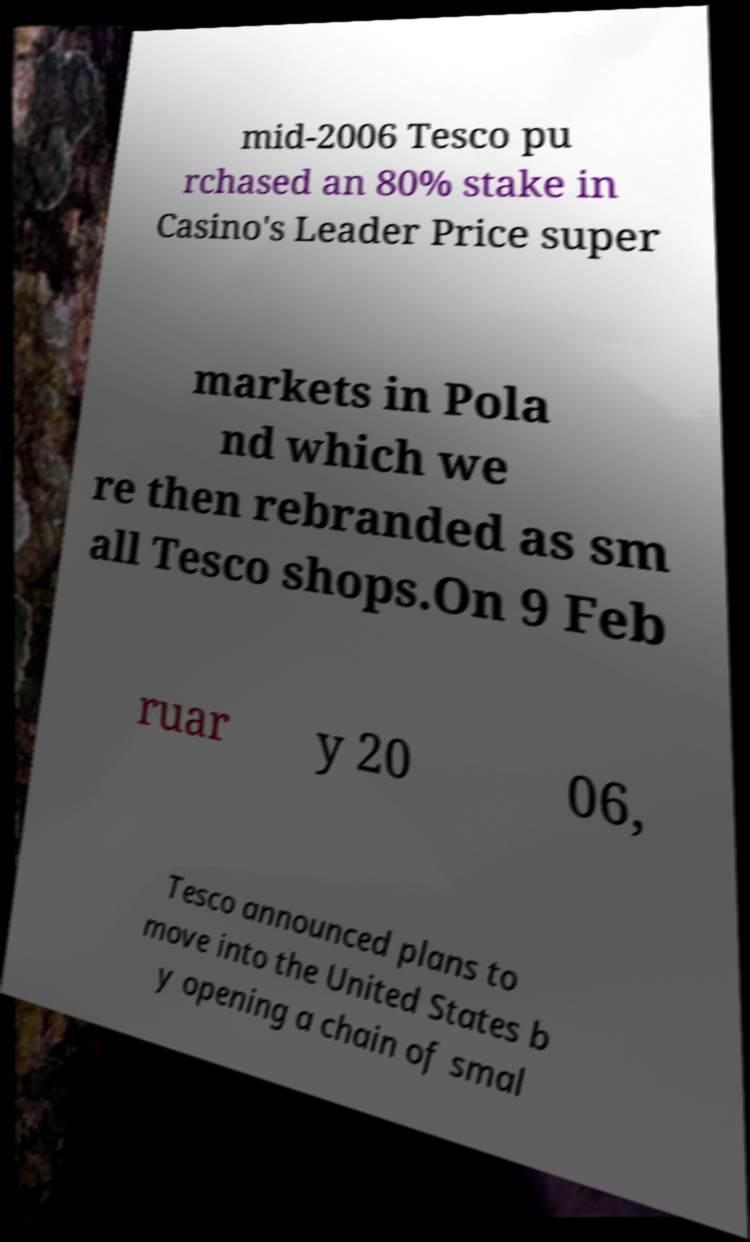What messages or text are displayed in this image? I need them in a readable, typed format. mid-2006 Tesco pu rchased an 80% stake in Casino's Leader Price super markets in Pola nd which we re then rebranded as sm all Tesco shops.On 9 Feb ruar y 20 06, Tesco announced plans to move into the United States b y opening a chain of smal 